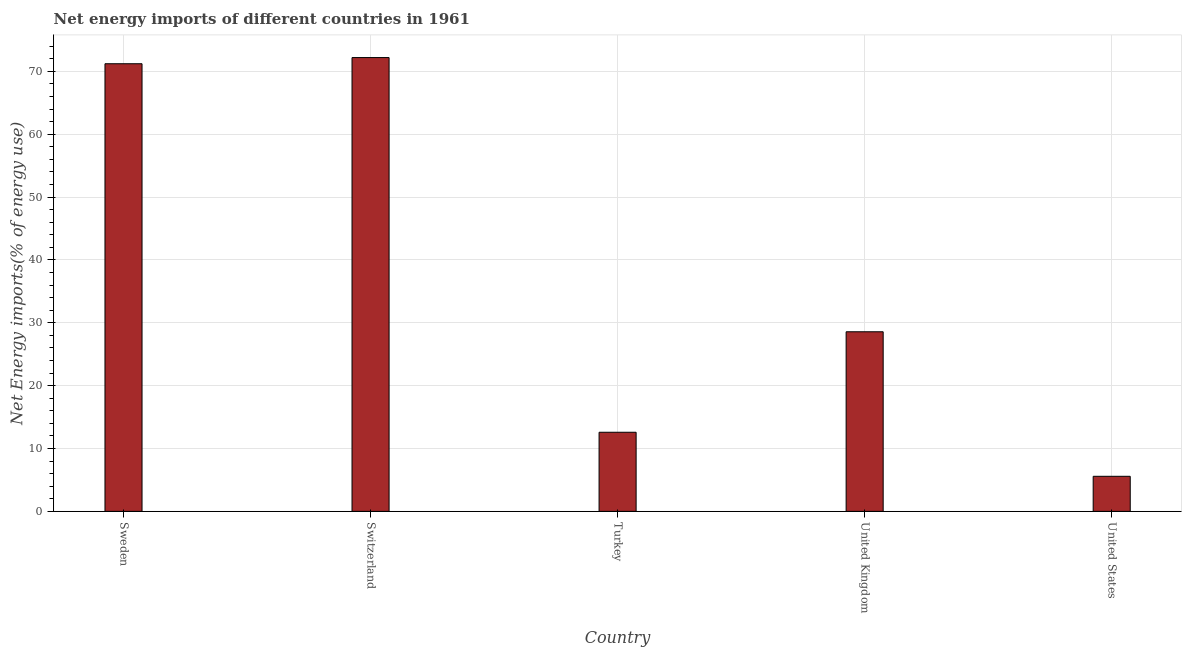Does the graph contain any zero values?
Give a very brief answer. No. What is the title of the graph?
Ensure brevity in your answer.  Net energy imports of different countries in 1961. What is the label or title of the X-axis?
Offer a very short reply. Country. What is the label or title of the Y-axis?
Your answer should be very brief. Net Energy imports(% of energy use). What is the energy imports in United States?
Give a very brief answer. 5.58. Across all countries, what is the maximum energy imports?
Your response must be concise. 72.21. Across all countries, what is the minimum energy imports?
Provide a short and direct response. 5.58. In which country was the energy imports maximum?
Give a very brief answer. Switzerland. In which country was the energy imports minimum?
Your answer should be very brief. United States. What is the sum of the energy imports?
Provide a succinct answer. 190.17. What is the difference between the energy imports in Sweden and United Kingdom?
Your response must be concise. 42.65. What is the average energy imports per country?
Ensure brevity in your answer.  38.03. What is the median energy imports?
Your response must be concise. 28.58. What is the ratio of the energy imports in Switzerland to that in United Kingdom?
Offer a terse response. 2.53. What is the difference between the highest and the second highest energy imports?
Offer a terse response. 0.98. What is the difference between the highest and the lowest energy imports?
Ensure brevity in your answer.  66.63. How many bars are there?
Provide a short and direct response. 5. What is the Net Energy imports(% of energy use) of Sweden?
Your answer should be compact. 71.22. What is the Net Energy imports(% of energy use) of Switzerland?
Provide a short and direct response. 72.21. What is the Net Energy imports(% of energy use) of Turkey?
Give a very brief answer. 12.59. What is the Net Energy imports(% of energy use) in United Kingdom?
Ensure brevity in your answer.  28.58. What is the Net Energy imports(% of energy use) of United States?
Keep it short and to the point. 5.58. What is the difference between the Net Energy imports(% of energy use) in Sweden and Switzerland?
Ensure brevity in your answer.  -0.98. What is the difference between the Net Energy imports(% of energy use) in Sweden and Turkey?
Ensure brevity in your answer.  58.64. What is the difference between the Net Energy imports(% of energy use) in Sweden and United Kingdom?
Offer a terse response. 42.65. What is the difference between the Net Energy imports(% of energy use) in Sweden and United States?
Keep it short and to the point. 65.65. What is the difference between the Net Energy imports(% of energy use) in Switzerland and Turkey?
Offer a terse response. 59.62. What is the difference between the Net Energy imports(% of energy use) in Switzerland and United Kingdom?
Offer a very short reply. 43.63. What is the difference between the Net Energy imports(% of energy use) in Switzerland and United States?
Provide a succinct answer. 66.63. What is the difference between the Net Energy imports(% of energy use) in Turkey and United Kingdom?
Provide a succinct answer. -15.99. What is the difference between the Net Energy imports(% of energy use) in Turkey and United States?
Your response must be concise. 7.01. What is the difference between the Net Energy imports(% of energy use) in United Kingdom and United States?
Your answer should be compact. 23. What is the ratio of the Net Energy imports(% of energy use) in Sweden to that in Switzerland?
Ensure brevity in your answer.  0.99. What is the ratio of the Net Energy imports(% of energy use) in Sweden to that in Turkey?
Keep it short and to the point. 5.66. What is the ratio of the Net Energy imports(% of energy use) in Sweden to that in United Kingdom?
Ensure brevity in your answer.  2.49. What is the ratio of the Net Energy imports(% of energy use) in Sweden to that in United States?
Ensure brevity in your answer.  12.77. What is the ratio of the Net Energy imports(% of energy use) in Switzerland to that in Turkey?
Offer a terse response. 5.74. What is the ratio of the Net Energy imports(% of energy use) in Switzerland to that in United Kingdom?
Ensure brevity in your answer.  2.53. What is the ratio of the Net Energy imports(% of energy use) in Switzerland to that in United States?
Your response must be concise. 12.94. What is the ratio of the Net Energy imports(% of energy use) in Turkey to that in United Kingdom?
Your response must be concise. 0.44. What is the ratio of the Net Energy imports(% of energy use) in Turkey to that in United States?
Keep it short and to the point. 2.26. What is the ratio of the Net Energy imports(% of energy use) in United Kingdom to that in United States?
Your response must be concise. 5.12. 